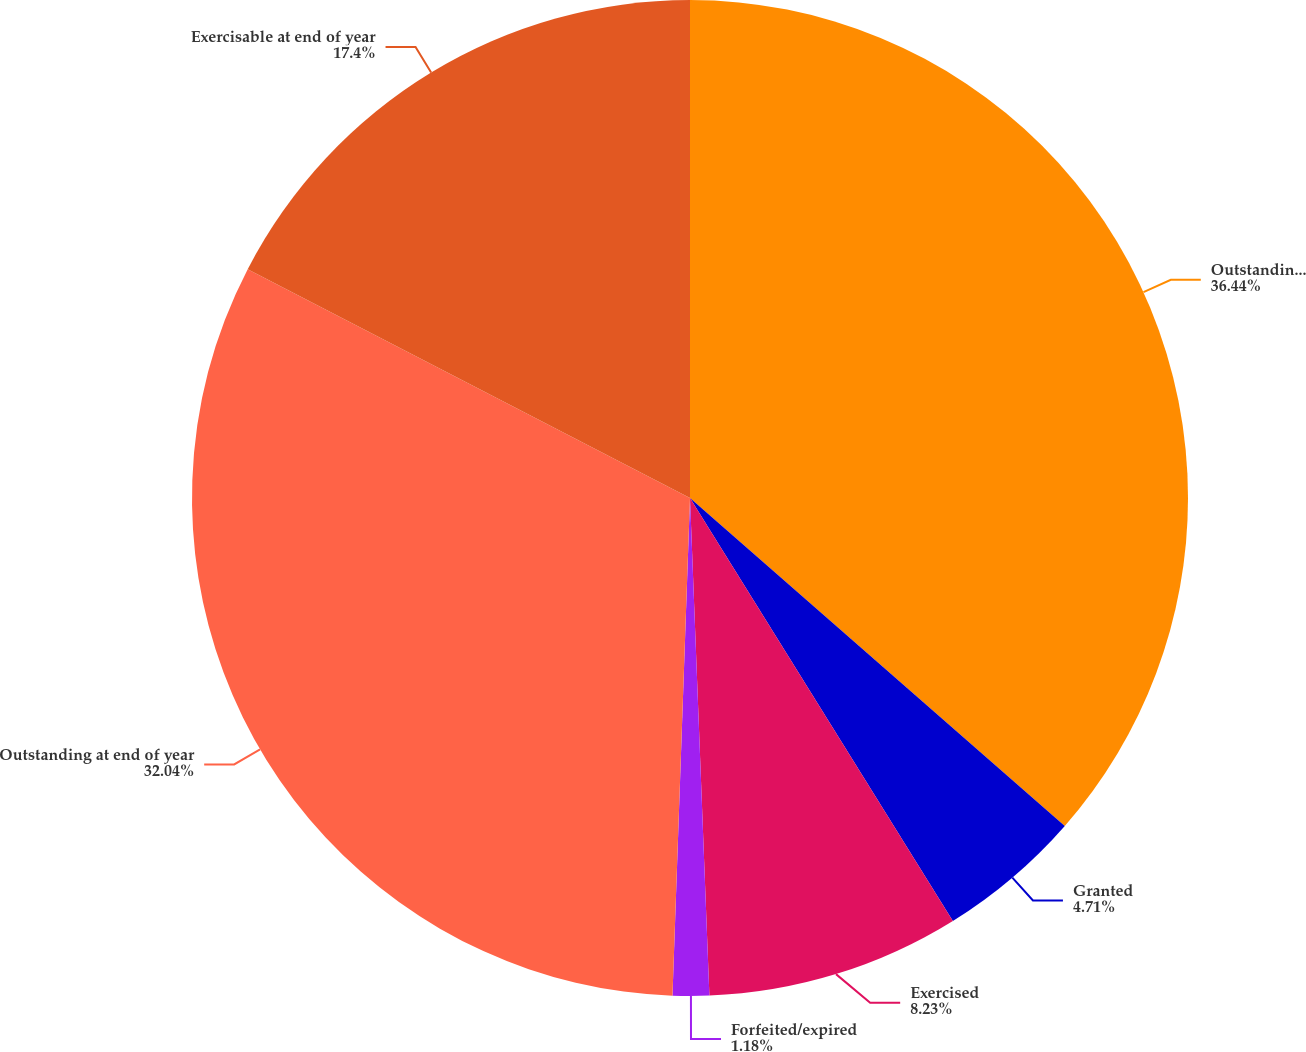Convert chart to OTSL. <chart><loc_0><loc_0><loc_500><loc_500><pie_chart><fcel>Outstanding at beginning of<fcel>Granted<fcel>Exercised<fcel>Forfeited/expired<fcel>Outstanding at end of year<fcel>Exercisable at end of year<nl><fcel>36.44%<fcel>4.71%<fcel>8.23%<fcel>1.18%<fcel>32.04%<fcel>17.4%<nl></chart> 